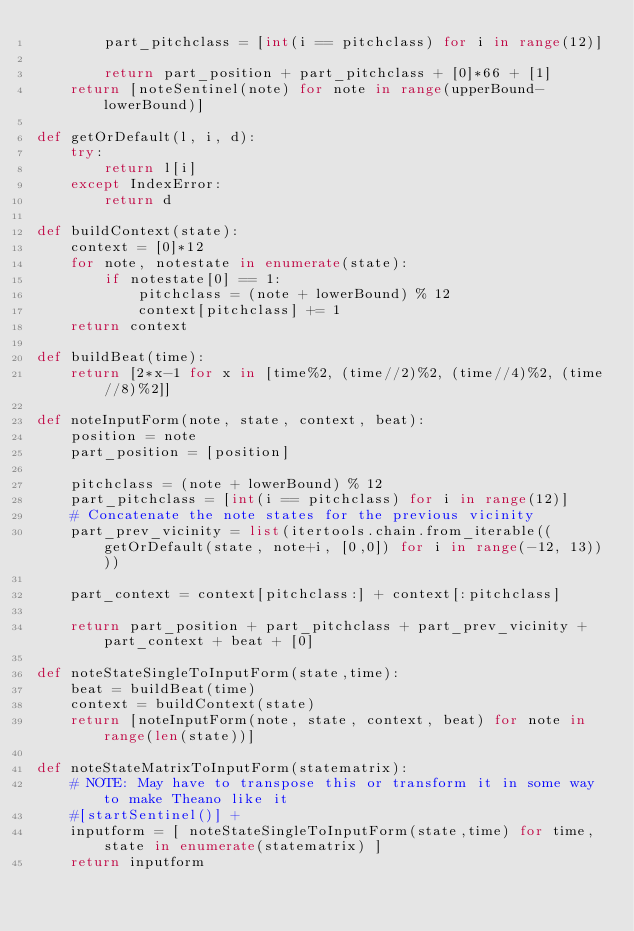Convert code to text. <code><loc_0><loc_0><loc_500><loc_500><_Python_>        part_pitchclass = [int(i == pitchclass) for i in range(12)]
        
        return part_position + part_pitchclass + [0]*66 + [1] 
    return [noteSentinel(note) for note in range(upperBound-lowerBound)]

def getOrDefault(l, i, d):
    try:
        return l[i]
    except IndexError:
        return d

def buildContext(state):
    context = [0]*12
    for note, notestate in enumerate(state):
        if notestate[0] == 1:
            pitchclass = (note + lowerBound) % 12
            context[pitchclass] += 1
    return context
    
def buildBeat(time):
    return [2*x-1 for x in [time%2, (time//2)%2, (time//4)%2, (time//8)%2]]

def noteInputForm(note, state, context, beat):
    position = note
    part_position = [position]

    pitchclass = (note + lowerBound) % 12
    part_pitchclass = [int(i == pitchclass) for i in range(12)]
    # Concatenate the note states for the previous vicinity
    part_prev_vicinity = list(itertools.chain.from_iterable((getOrDefault(state, note+i, [0,0]) for i in range(-12, 13))))

    part_context = context[pitchclass:] + context[:pitchclass]

    return part_position + part_pitchclass + part_prev_vicinity + part_context + beat + [0]

def noteStateSingleToInputForm(state,time):
    beat = buildBeat(time)
    context = buildContext(state)
    return [noteInputForm(note, state, context, beat) for note in range(len(state))]

def noteStateMatrixToInputForm(statematrix):
    # NOTE: May have to transpose this or transform it in some way to make Theano like it
    #[startSentinel()] + 
    inputform = [ noteStateSingleToInputForm(state,time) for time,state in enumerate(statematrix) ]
    return inputform
</code> 